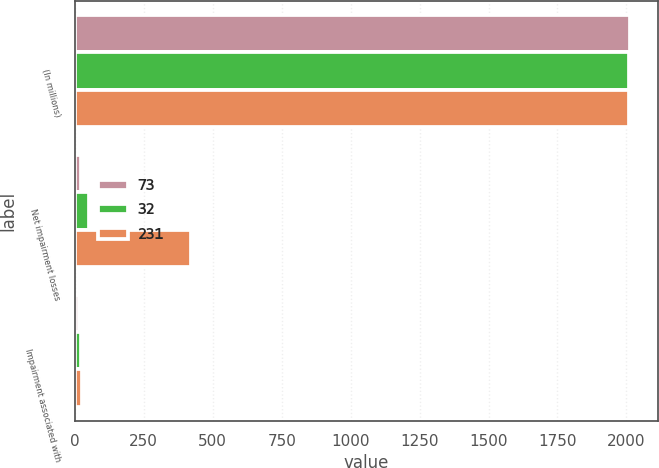<chart> <loc_0><loc_0><loc_500><loc_500><stacked_bar_chart><ecel><fcel>(In millions)<fcel>Net impairment losses<fcel>Impairment associated with<nl><fcel>73<fcel>2012<fcel>21<fcel>16<nl><fcel>32<fcel>2011<fcel>50<fcel>23<nl><fcel>231<fcel>2010<fcel>420<fcel>27<nl></chart> 